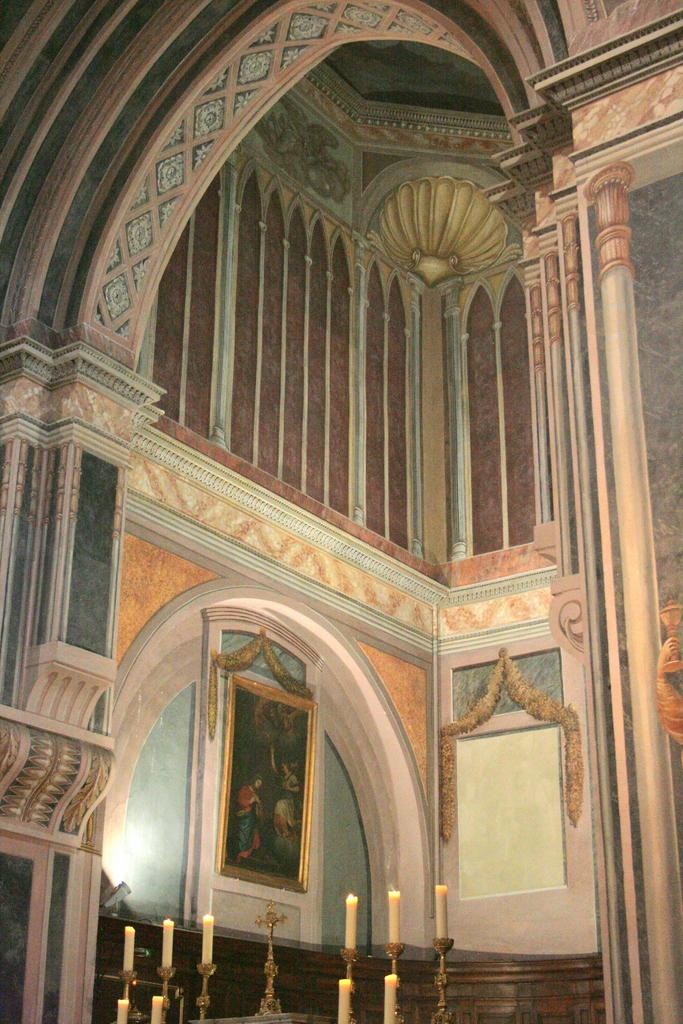What objects can be seen in the image that might be used for illumination? There are candles in the image that can be used for illumination. What religious symbol is present in the image? There is a cross in the image. What type of decorative items can be seen on the wall in the image? There are photo frames on the wall in the image. What type of class is being held in the image? There is no indication of a class or any educational activity in the image. Can you see any ghosts in the image? There are no ghosts present in the image. 